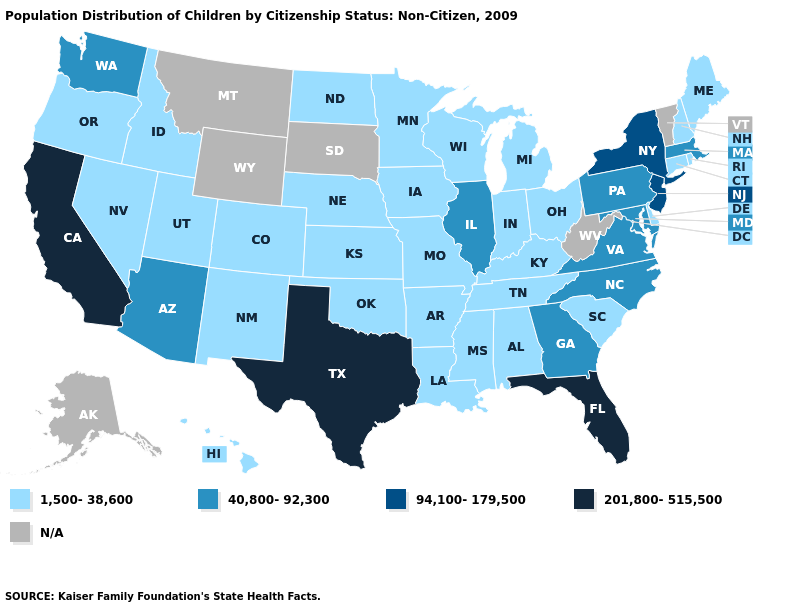What is the highest value in the USA?
Short answer required. 201,800-515,500. What is the value of Nevada?
Be succinct. 1,500-38,600. Name the states that have a value in the range 40,800-92,300?
Give a very brief answer. Arizona, Georgia, Illinois, Maryland, Massachusetts, North Carolina, Pennsylvania, Virginia, Washington. Name the states that have a value in the range 1,500-38,600?
Quick response, please. Alabama, Arkansas, Colorado, Connecticut, Delaware, Hawaii, Idaho, Indiana, Iowa, Kansas, Kentucky, Louisiana, Maine, Michigan, Minnesota, Mississippi, Missouri, Nebraska, Nevada, New Hampshire, New Mexico, North Dakota, Ohio, Oklahoma, Oregon, Rhode Island, South Carolina, Tennessee, Utah, Wisconsin. Among the states that border Delaware , which have the lowest value?
Be succinct. Maryland, Pennsylvania. Does Illinois have the lowest value in the MidWest?
Be succinct. No. Which states have the lowest value in the USA?
Write a very short answer. Alabama, Arkansas, Colorado, Connecticut, Delaware, Hawaii, Idaho, Indiana, Iowa, Kansas, Kentucky, Louisiana, Maine, Michigan, Minnesota, Mississippi, Missouri, Nebraska, Nevada, New Hampshire, New Mexico, North Dakota, Ohio, Oklahoma, Oregon, Rhode Island, South Carolina, Tennessee, Utah, Wisconsin. Name the states that have a value in the range N/A?
Give a very brief answer. Alaska, Montana, South Dakota, Vermont, West Virginia, Wyoming. Does Illinois have the highest value in the MidWest?
Keep it brief. Yes. How many symbols are there in the legend?
Write a very short answer. 5. Does Louisiana have the lowest value in the South?
Be succinct. Yes. What is the highest value in the USA?
Be succinct. 201,800-515,500. What is the value of Missouri?
Keep it brief. 1,500-38,600. Does Washington have the lowest value in the USA?
Give a very brief answer. No. 